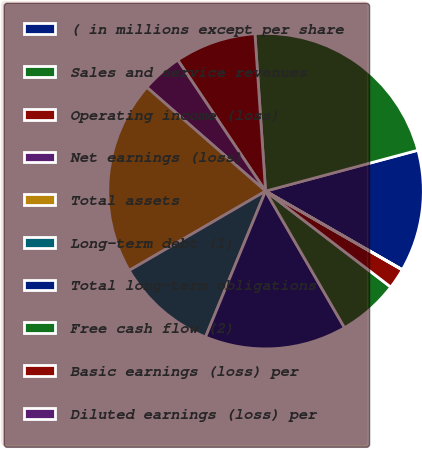Convert chart to OTSL. <chart><loc_0><loc_0><loc_500><loc_500><pie_chart><fcel>( in millions except per share<fcel>Sales and service revenues<fcel>Operating income (loss)<fcel>Net earnings (loss)<fcel>Total assets<fcel>Long-term debt (1)<fcel>Total long-term obligations<fcel>Free cash flow (2)<fcel>Basic earnings (loss) per<fcel>Diluted earnings (loss) per<nl><fcel>12.48%<fcel>21.9%<fcel>8.32%<fcel>4.17%<fcel>19.82%<fcel>10.4%<fcel>14.56%<fcel>6.25%<fcel>2.09%<fcel>0.01%<nl></chart> 